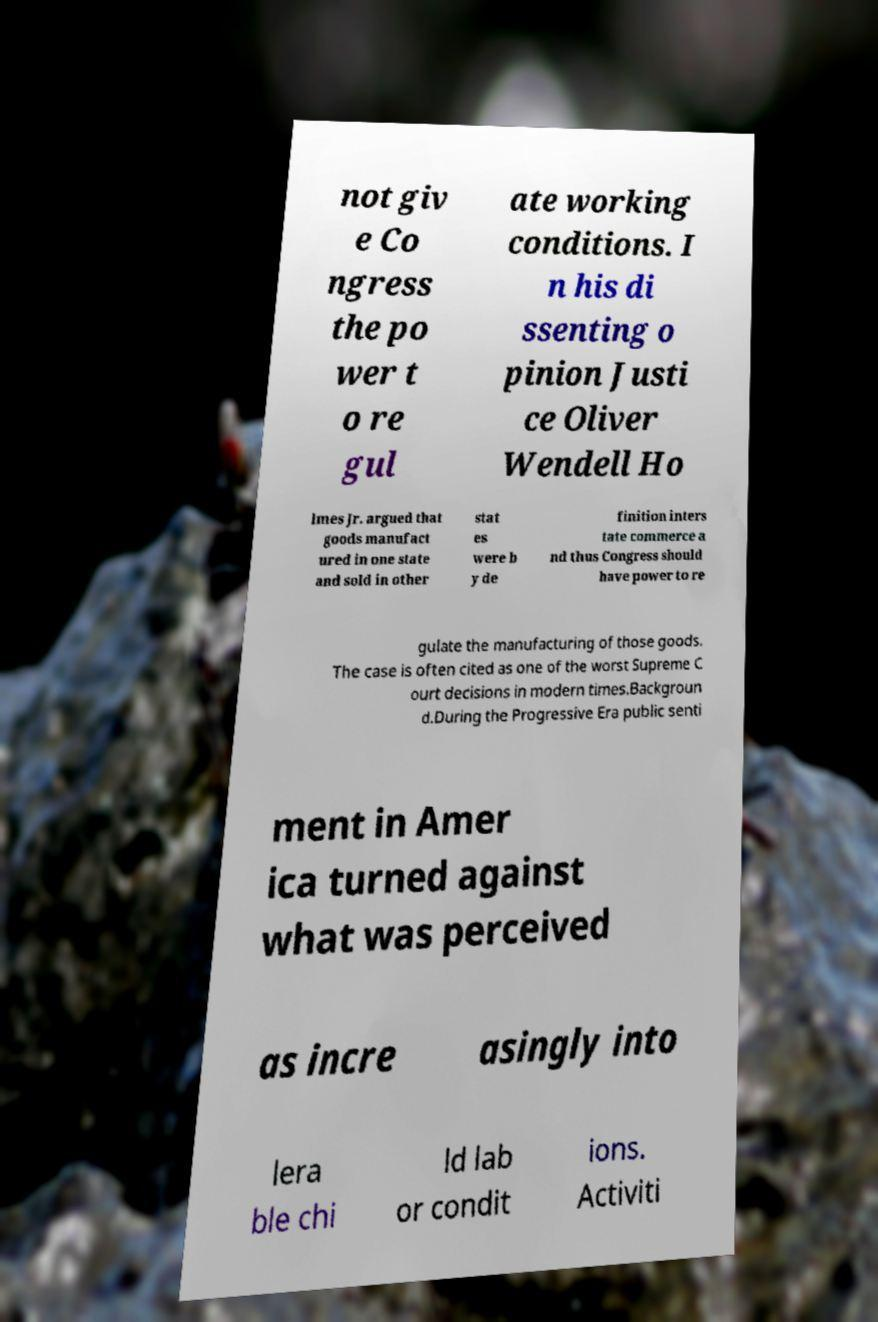What messages or text are displayed in this image? I need them in a readable, typed format. not giv e Co ngress the po wer t o re gul ate working conditions. I n his di ssenting o pinion Justi ce Oliver Wendell Ho lmes Jr. argued that goods manufact ured in one state and sold in other stat es were b y de finition inters tate commerce a nd thus Congress should have power to re gulate the manufacturing of those goods. The case is often cited as one of the worst Supreme C ourt decisions in modern times.Backgroun d.During the Progressive Era public senti ment in Amer ica turned against what was perceived as incre asingly into lera ble chi ld lab or condit ions. Activiti 